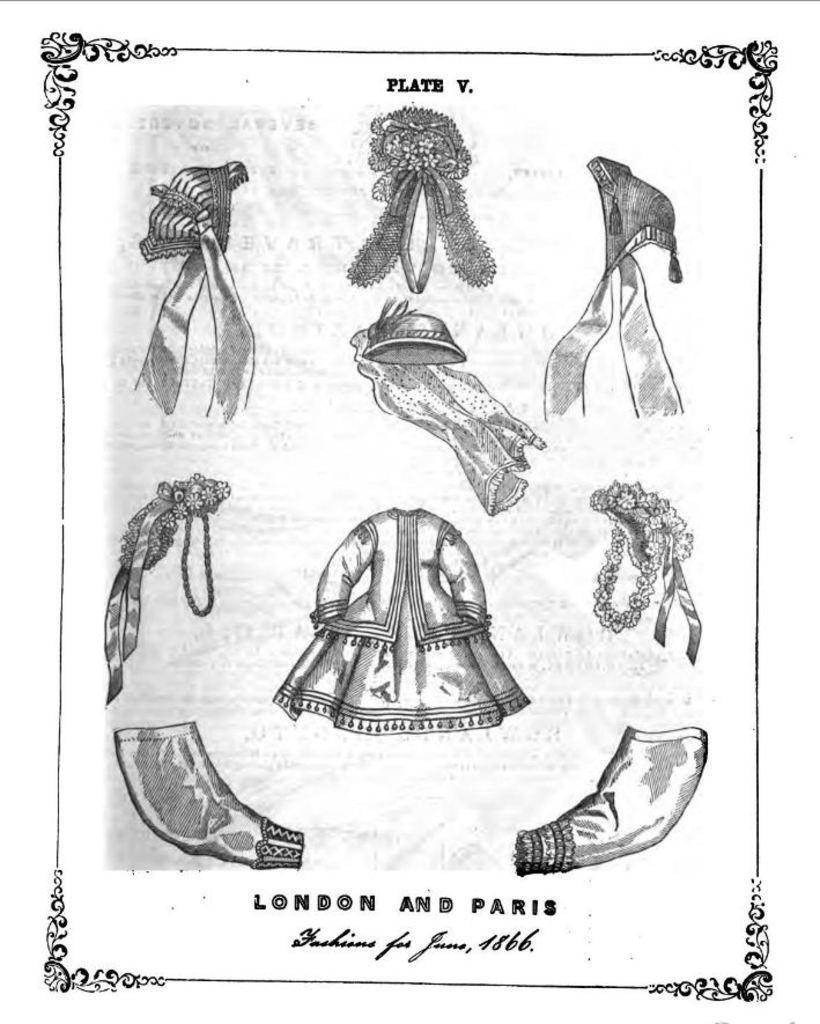Please provide a concise description of this image. In this image I can see a drawing of clothes and accessories, there are borders and some matter is written at the bottom. This is a black and white image. 